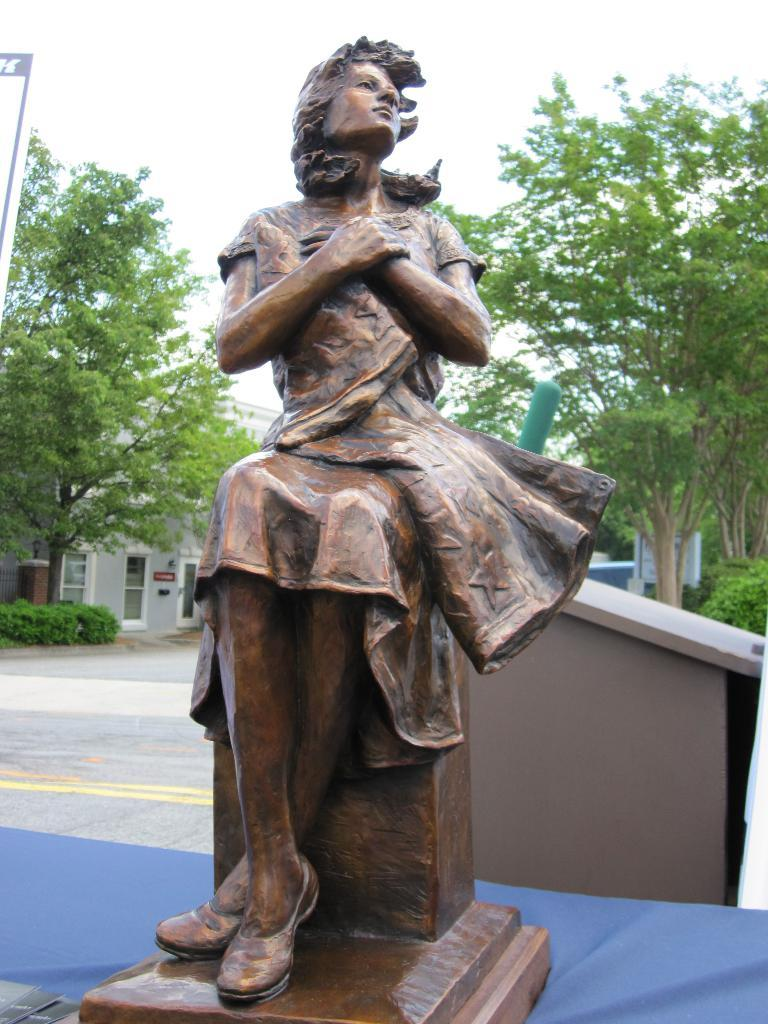What is the main subject in the center of the image? There is a statue in the center of the image. What can be seen in the background of the image? In the background of the image, there is a dustbin, trees, buildings, a road, and the sky. Can you describe the setting of the image? The image appears to be set in an urban environment, with buildings and a road visible in the background. What type of hair can be seen on the statue in the image? There is no hair visible on the statue in the image. Is there a potato growing in the background of the image? There is no potato visible in the image. Can you see a church in the background of the image? There is no church visible in the image. 